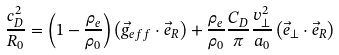<formula> <loc_0><loc_0><loc_500><loc_500>\frac { c _ { D } ^ { 2 } } { R _ { 0 } } = \left ( 1 - \frac { \rho _ { e } } { \rho _ { 0 } } \right ) \left ( \vec { g } _ { e f f } \cdot \vec { e } _ { R } \right ) + \frac { \rho _ { e } } { \rho _ { 0 } } \frac { C _ { D } } { \pi } \frac { v _ { \perp } ^ { 2 } } { a _ { 0 } } \left ( \vec { e } _ { \perp } \cdot \vec { e } _ { R } \right )</formula> 